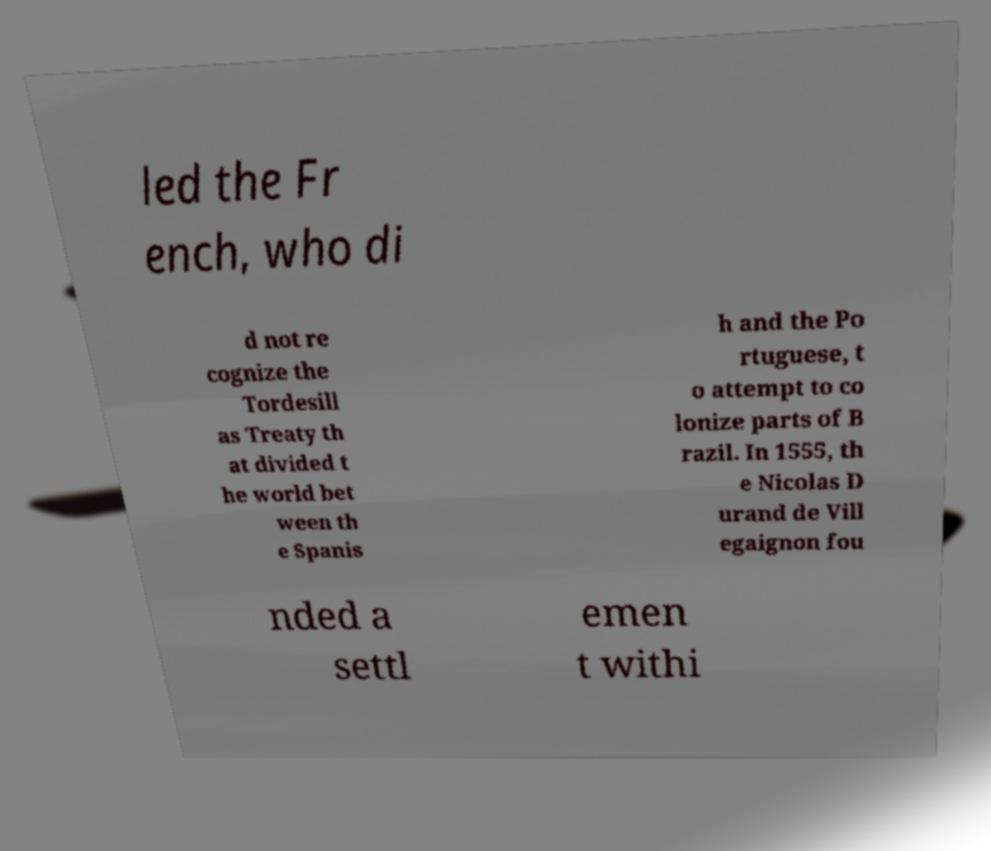Could you extract and type out the text from this image? led the Fr ench, who di d not re cognize the Tordesill as Treaty th at divided t he world bet ween th e Spanis h and the Po rtuguese, t o attempt to co lonize parts of B razil. In 1555, th e Nicolas D urand de Vill egaignon fou nded a settl emen t withi 